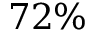Convert formula to latex. <formula><loc_0><loc_0><loc_500><loc_500>7 2 \%</formula> 